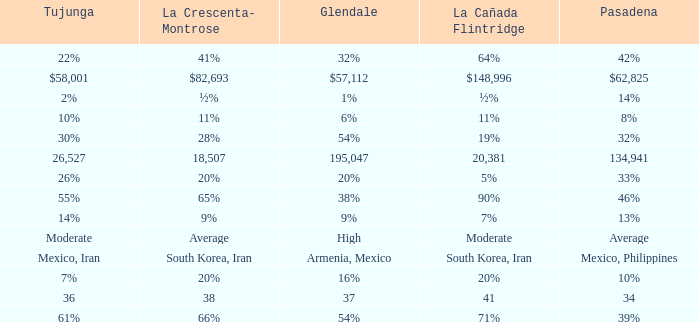When La Crescenta-Montrose has 66%, what is Tujunga? 61%. 